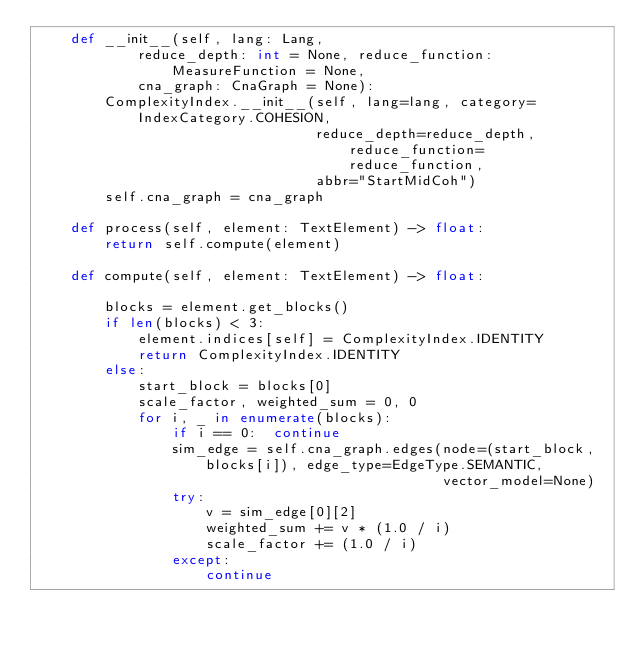<code> <loc_0><loc_0><loc_500><loc_500><_Python_>    def __init__(self, lang: Lang,
            reduce_depth: int = None, reduce_function: MeasureFunction = None,
            cna_graph: CnaGraph = None):
        ComplexityIndex.__init__(self, lang=lang, category=IndexCategory.COHESION,
                                 reduce_depth=reduce_depth, reduce_function=reduce_function,
                                 abbr="StartMidCoh")
        self.cna_graph = cna_graph
        
    def process(self, element: TextElement) -> float:
        return self.compute(element)

    def compute(self, element: TextElement) -> float:

        blocks = element.get_blocks()
        if len(blocks) < 3:
            element.indices[self] = ComplexityIndex.IDENTITY
            return ComplexityIndex.IDENTITY            
        else:
            start_block = blocks[0]
            scale_factor, weighted_sum = 0, 0
            for i, _ in enumerate(blocks):
                if i == 0:  continue
                sim_edge = self.cna_graph.edges(node=(start_block, blocks[i]), edge_type=EdgeType.SEMANTIC, 
                                                vector_model=None)
                try:                                    
                    v = sim_edge[0][2]
                    weighted_sum += v * (1.0 / i)
                    scale_factor += (1.0 / i)
                except:
                    continue    </code> 